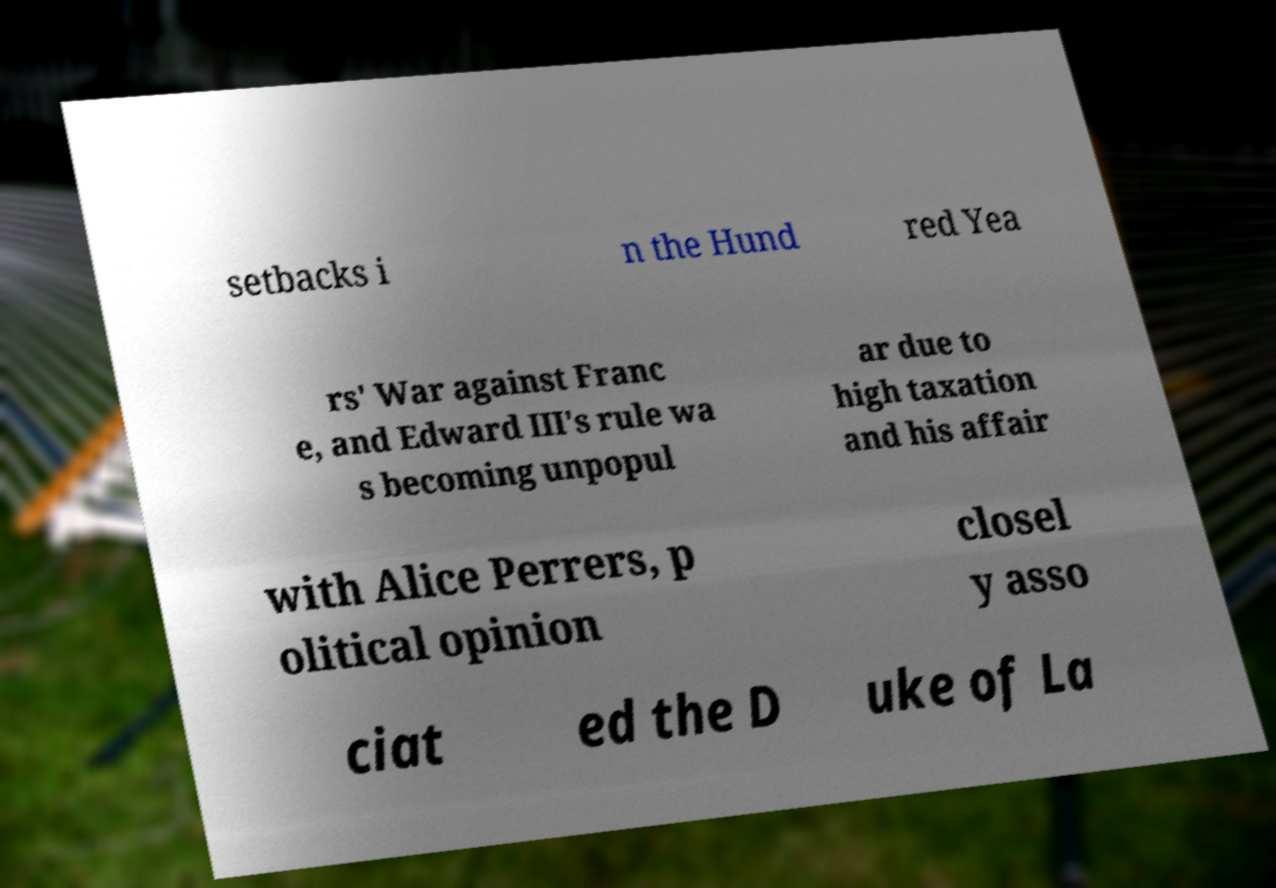Could you extract and type out the text from this image? setbacks i n the Hund red Yea rs' War against Franc e, and Edward III's rule wa s becoming unpopul ar due to high taxation and his affair with Alice Perrers, p olitical opinion closel y asso ciat ed the D uke of La 